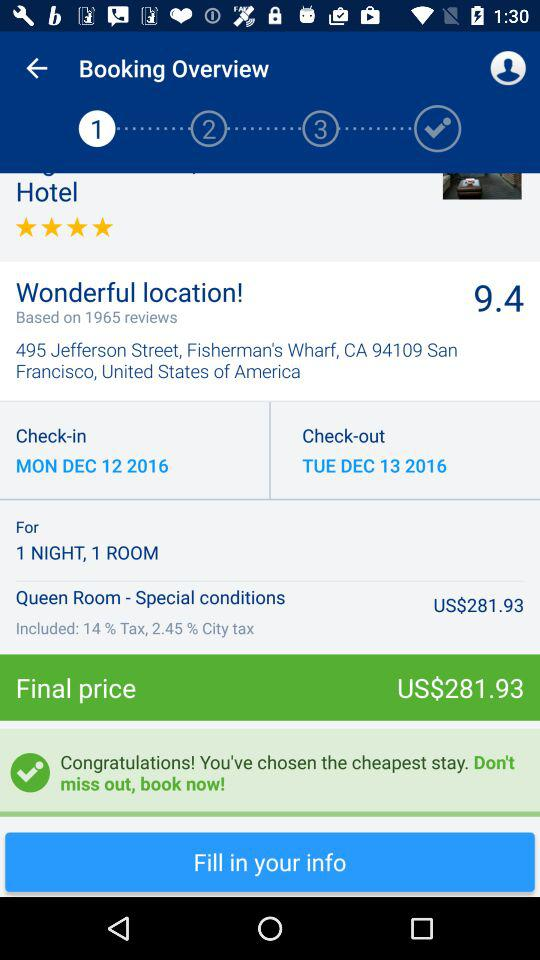What is the check-out date? The check-out date is Tuesday, December 13, 2016. 